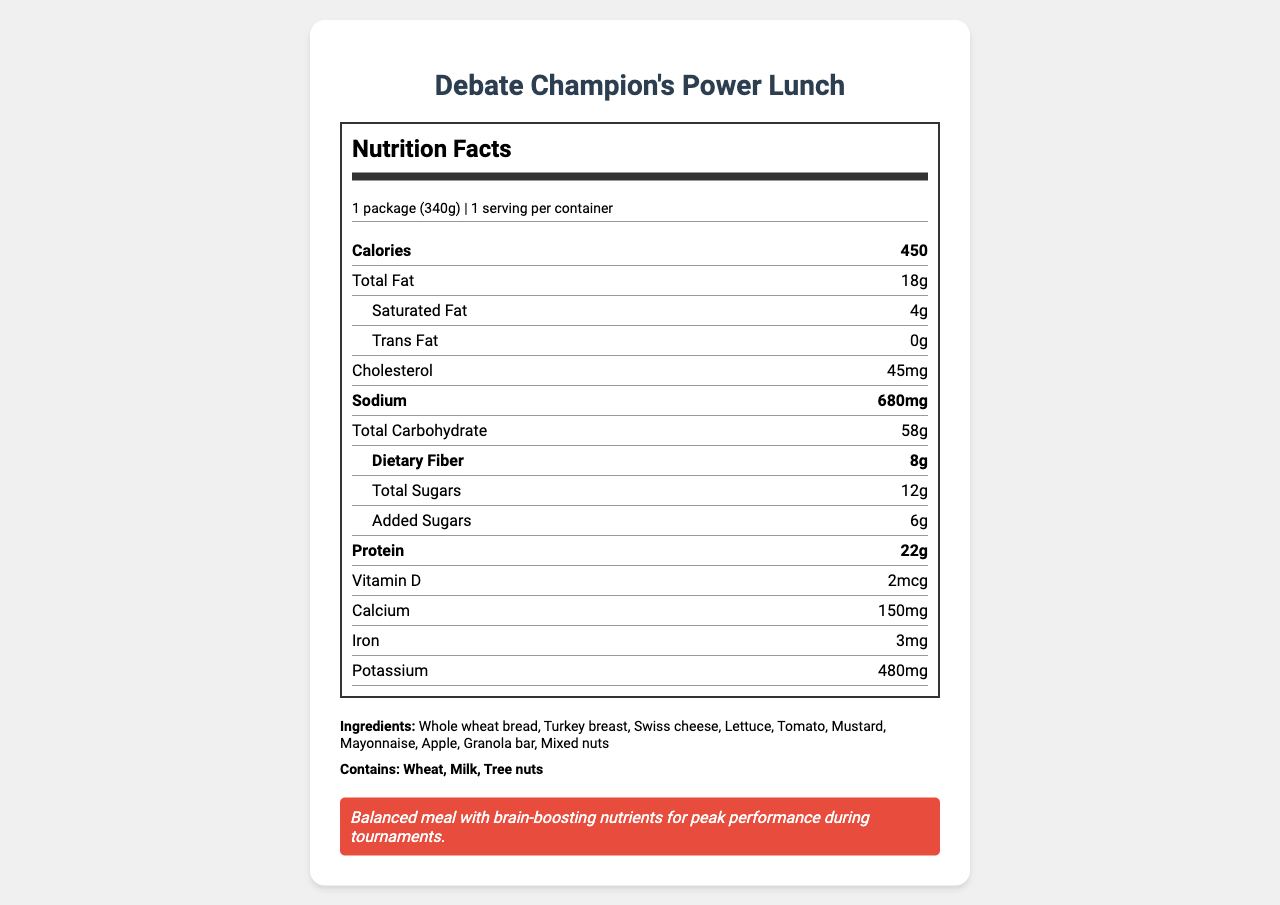what is the serving size of the package? The serving size is listed at the beginning of the Nutrition Facts label as 1 package (340g).
Answer: 1 package (340g) how many calories does one serving contain? The calories per serving are displayed prominently near the top of the Nutrition Facts label.
Answer: 450 What is the total carbohydrate content per serving? The total carbohydrate content is included in the nutrient section of the label and is indicated as 58g.
Answer: 58g how much sodium does the product contain? The sodium content is bolded in the nutrition label and it is 680mg.
Answer: 680mg how much dietary fiber is in one serving? The dietary fiber is listed under the total carbohydrate section and it is bolded as 8g.
Answer: 8g how much protein does the package have? The protein content is highlighted in bold and marked as 22g per serving.
Answer: 22g Which of the following allergens are present in the product? A. Soy B. Wheat C. Shellfish D. Peanuts The allergens section lists "Wheat," "Milk," and "Tree nuts," but does not mention soy, shellfish, or peanuts.
Answer: B. Wheat The product contains: A. 200mg of cholesterol B. 150mg of calcium C. 2g of trans fat D. 30g of sugar The calcium content is listed as 150mg, making it the correct answer. The other values given do not match the data on the label.
Answer: B. 150mg of calcium Is there any trans fat in the product? The trans fat content is listed as 0g which means there is no trans fat in the product.
Answer: No What is the main idea of the document? This includes the primary features of the document such as the type of product, nutritional facts, ingredients, allergens, preparation instructions, and an encouraging note.
Answer: The document provides a detailed Nutrition Facts label for the Debate Champion's Power Lunch, including its nutritional information, ingredients, allergens, preparation instructions, and a note about its benefits for debate club performance. what cooking instructions are provided? The document mentions preparation instructions: "Keep refrigerated. Consume within 4 hours if not refrigerated," but no cooking instructions are provided.
Answer: Not enough information 